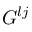<formula> <loc_0><loc_0><loc_500><loc_500>G ^ { l j }</formula> 